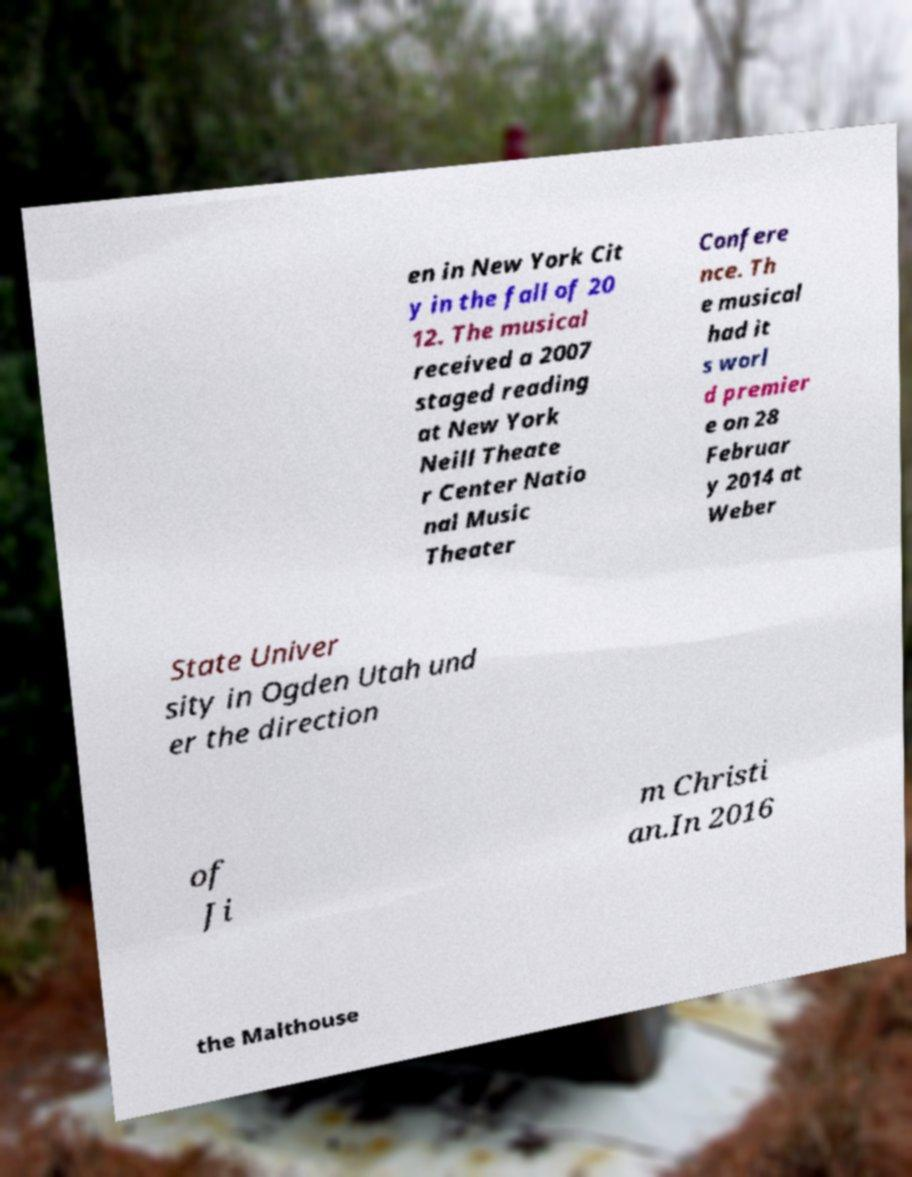Can you accurately transcribe the text from the provided image for me? en in New York Cit y in the fall of 20 12. The musical received a 2007 staged reading at New York Neill Theate r Center Natio nal Music Theater Confere nce. Th e musical had it s worl d premier e on 28 Februar y 2014 at Weber State Univer sity in Ogden Utah und er the direction of Ji m Christi an.In 2016 the Malthouse 